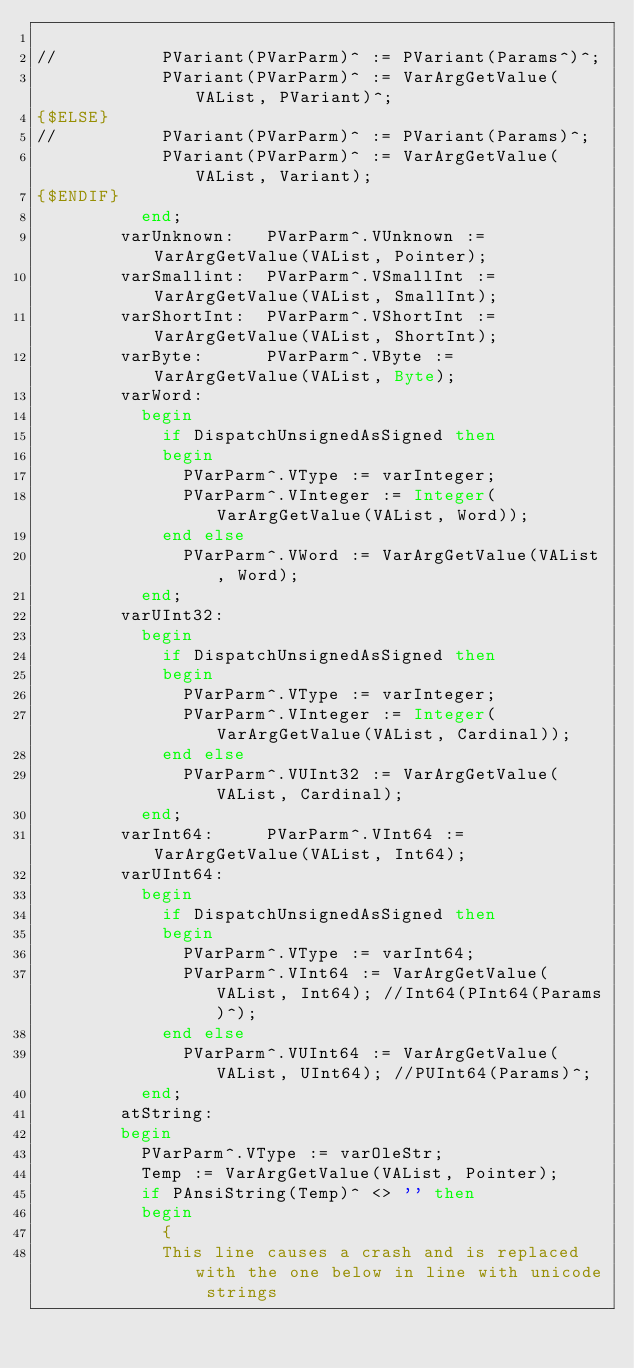Convert code to text. <code><loc_0><loc_0><loc_500><loc_500><_Pascal_>
//          PVariant(PVarParm)^ := PVariant(Params^)^;
            PVariant(PVarParm)^ := VarArgGetValue(VAList, PVariant)^;
{$ELSE}
//          PVariant(PVarParm)^ := PVariant(Params)^;
            PVariant(PVarParm)^ := VarArgGetValue(VAList, Variant);
{$ENDIF}
          end;
        varUnknown:   PVarParm^.VUnknown := VarArgGetValue(VAList, Pointer);
        varSmallint:  PVarParm^.VSmallInt := VarArgGetValue(VAList, SmallInt);
        varShortInt:  PVarParm^.VShortInt := VarArgGetValue(VAList, ShortInt);
        varByte:      PVarParm^.VByte :=  VarArgGetValue(VAList, Byte);
        varWord:
          begin
            if DispatchUnsignedAsSigned then
            begin
              PVarParm^.VType := varInteger;
              PVarParm^.VInteger := Integer(VarArgGetValue(VAList, Word));
            end else
              PVarParm^.VWord := VarArgGetValue(VAList, Word);
          end;
        varUInt32:
          begin
            if DispatchUnsignedAsSigned then
            begin
              PVarParm^.VType := varInteger;
              PVarParm^.VInteger := Integer(VarArgGetValue(VAList, Cardinal));
            end else
              PVarParm^.VUInt32 := VarArgGetValue(VAList, Cardinal);
          end;
        varInt64:     PVarParm^.VInt64 := VarArgGetValue(VAList, Int64);
        varUInt64:
          begin
            if DispatchUnsignedAsSigned then
            begin
              PVarParm^.VType := varInt64;
              PVarParm^.VInt64 := VarArgGetValue(VAList, Int64); //Int64(PInt64(Params)^);
            end else
              PVarParm^.VUInt64 := VarArgGetValue(VAList, UInt64); //PUInt64(Params)^;
          end;
        atString:
        begin
          PVarParm^.VType := varOleStr;
          Temp := VarArgGetValue(VAList, Pointer);
          if PAnsiString(Temp)^ <> '' then
          begin
            {
            This line causes a crash and is replaced with the one below in line with unicode strings</code> 